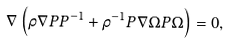<formula> <loc_0><loc_0><loc_500><loc_500>\nabla \left ( \rho \nabla P P ^ { - 1 } + \rho ^ { - 1 } P \nabla \Omega P \Omega \right ) = 0 ,</formula> 